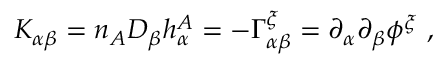Convert formula to latex. <formula><loc_0><loc_0><loc_500><loc_500>K _ { \alpha \beta } = n _ { A } D _ { \beta } h _ { \alpha } ^ { A } = - \Gamma _ { \alpha \beta } ^ { \xi } = \partial _ { \alpha } \partial _ { \beta } \phi ^ { \xi } ,</formula> 